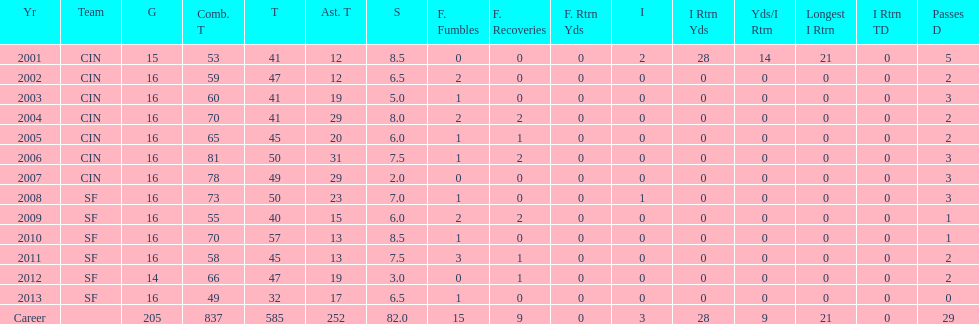How many years did he play in less than 16 games? 2. 